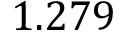Convert formula to latex. <formula><loc_0><loc_0><loc_500><loc_500>1 . 2 7 9</formula> 